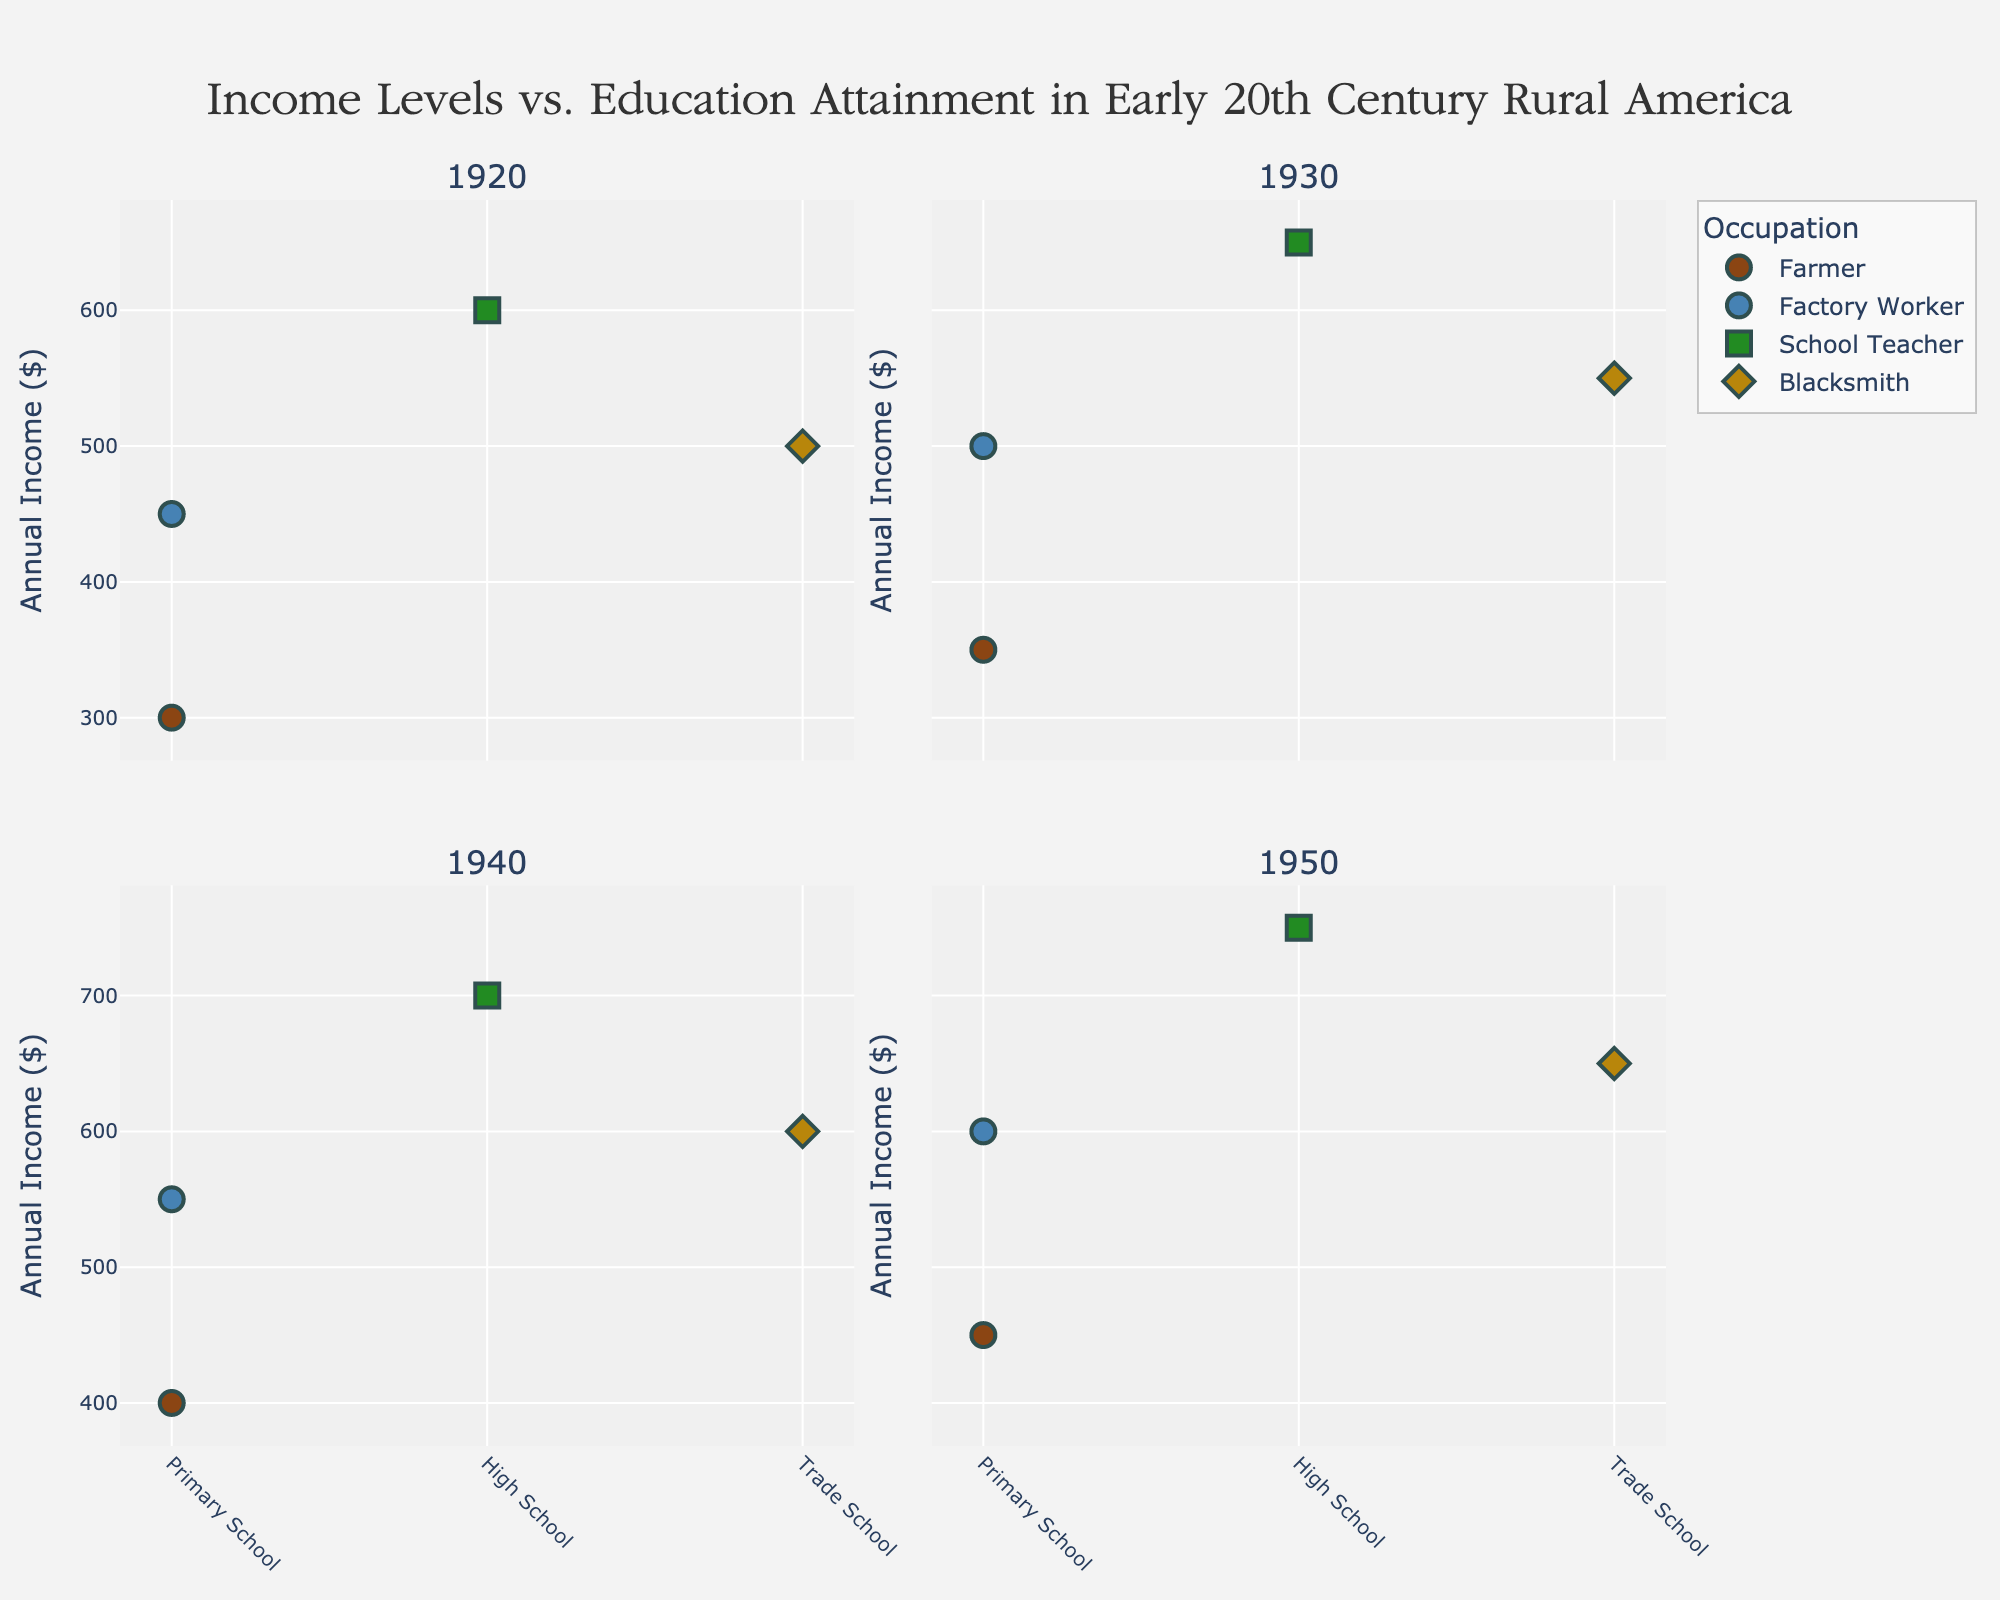What is the title of the figure? The title appears at the top center of the figure, it reads "Income Levels vs. Education Attainment in Early 20th Century Rural America".
Answer: Income Levels vs. Education Attainment in Early 20th Century Rural America Which occupation has the highest annual income in 1950? By looking at the subplot corresponding to 1950, locate the highest data point among the different occupations. "School Teacher" in 1950 has the highest annual income.
Answer: School Teacher In which year did farmers have the lowest annual income? Check each subplot corresponding to the years 1920, 1930, 1940, and 1950 for farmers' income. The lowest income for farmers is seen in the 1920 subplot.
Answer: 1920 How does the income of factory workers evolve from 1920 to 1950? Track the data points for factory workers across the different subplots. The annual income for factory workers increases from $450 in 1920 to $600 in 1950.
Answer: Increased from $450 to $600 Which education attainment level is associated with the highest income across all years? Identify data points with the highest incomes in each subplot and note the education attainment levels. Across all subplots, "High School" is repeatedly associated with the highest incomes.
Answer: High School Compare the income of blacksmiths and farmers in 1940. Which occupation had a higher income? In the 1940 subplot, compare the data points for blacksmiths and farmers. Blacksmiths had a higher annual income compared to farmers in 1940.
Answer: Blacksmiths Which year shows the smallest range of incomes across all occupations? Calculate the range of incomes (difference between the highest and lowest income) in each subplot and identify the smallest one. The year 1920 shows the smallest range of incomes.
Answer: 1920 How many occupations are represented in the figure? Count distinct occupation labels in any one of the subplots. All subplots show four occupations: Farmer, Factory Worker, School Teacher, and Blacksmith.
Answer: Four Across all years, which education level shows the most consistent increase in income? Track the income levels for each education attainment level across all four subplots and determine which shows a steady increase. The "Primary School" level exhibits this pattern.
Answer: Primary School 